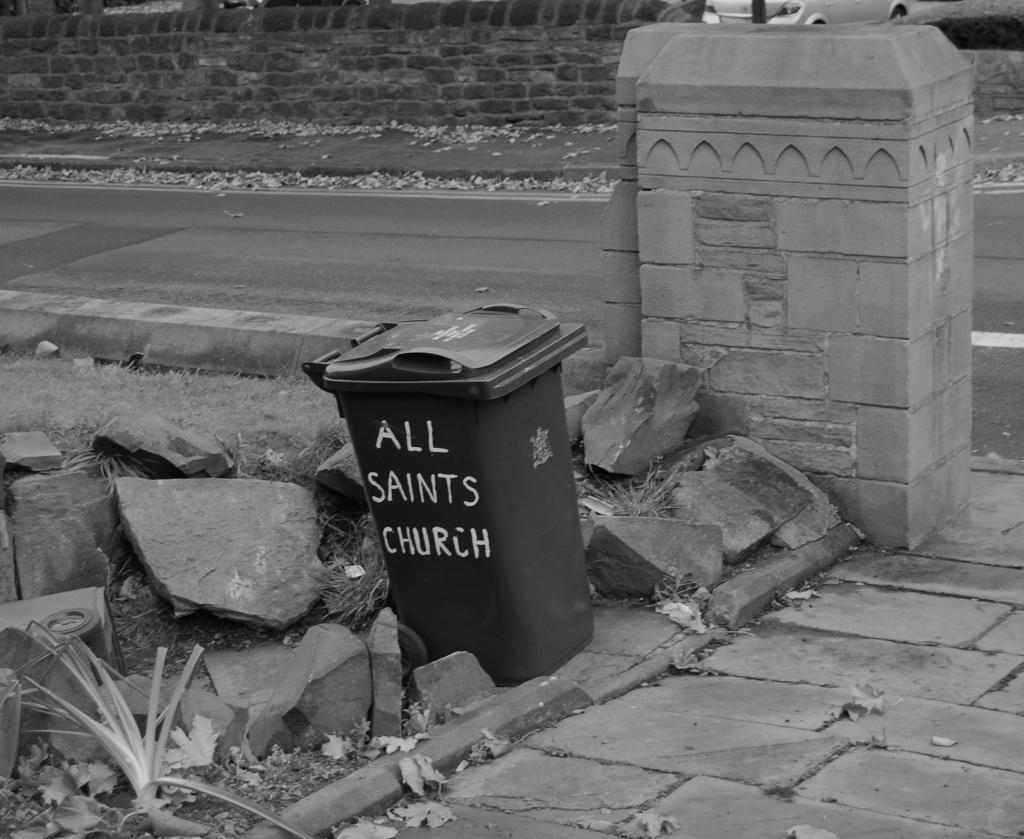<image>
Render a clear and concise summary of the photo. A trash can in black and white saying All saints church 